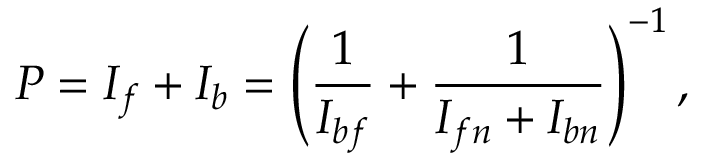Convert formula to latex. <formula><loc_0><loc_0><loc_500><loc_500>P = I _ { f } + I _ { b } = \left ( \frac { 1 } { I _ { b f } } + \frac { 1 } { I _ { f n } + I _ { b n } } \right ) ^ { - 1 } ,</formula> 